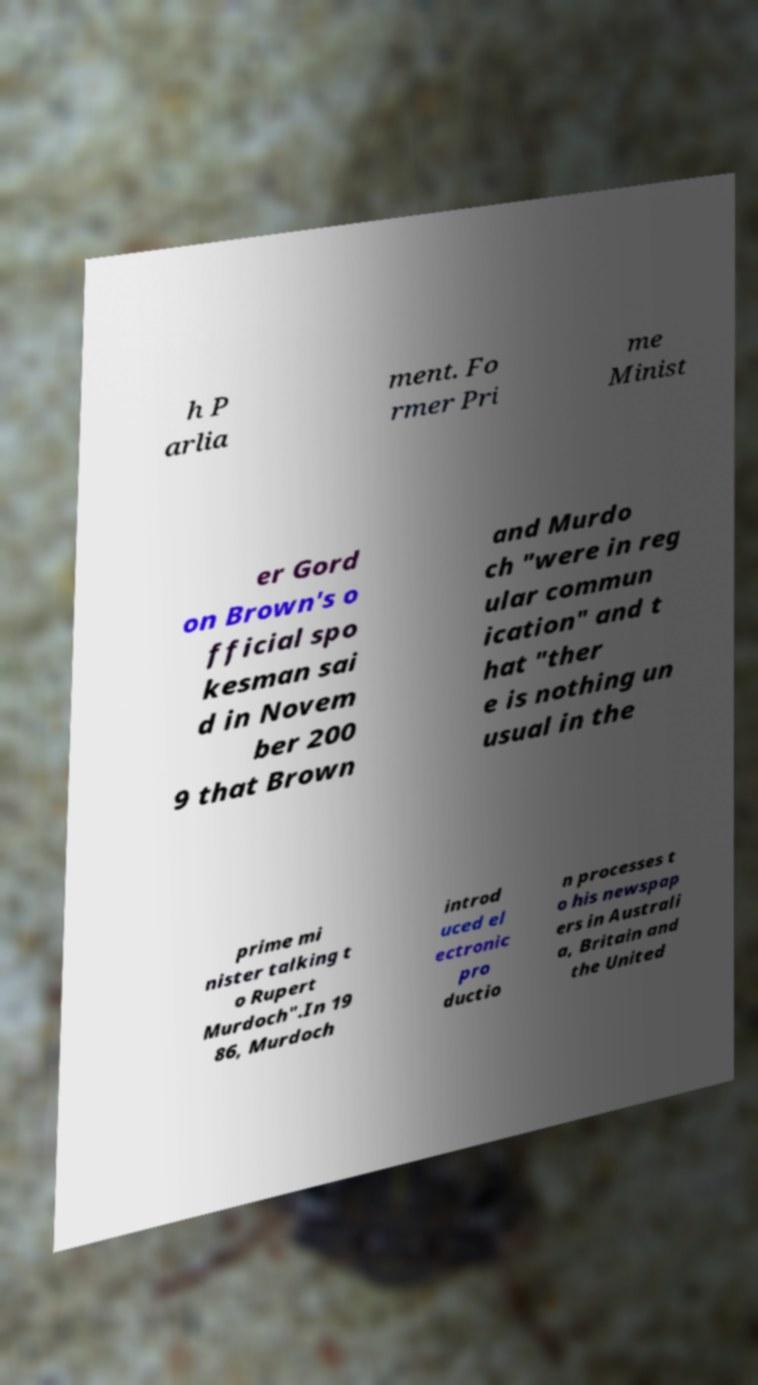Can you read and provide the text displayed in the image?This photo seems to have some interesting text. Can you extract and type it out for me? h P arlia ment. Fo rmer Pri me Minist er Gord on Brown's o fficial spo kesman sai d in Novem ber 200 9 that Brown and Murdo ch "were in reg ular commun ication" and t hat "ther e is nothing un usual in the prime mi nister talking t o Rupert Murdoch".In 19 86, Murdoch introd uced el ectronic pro ductio n processes t o his newspap ers in Australi a, Britain and the United 